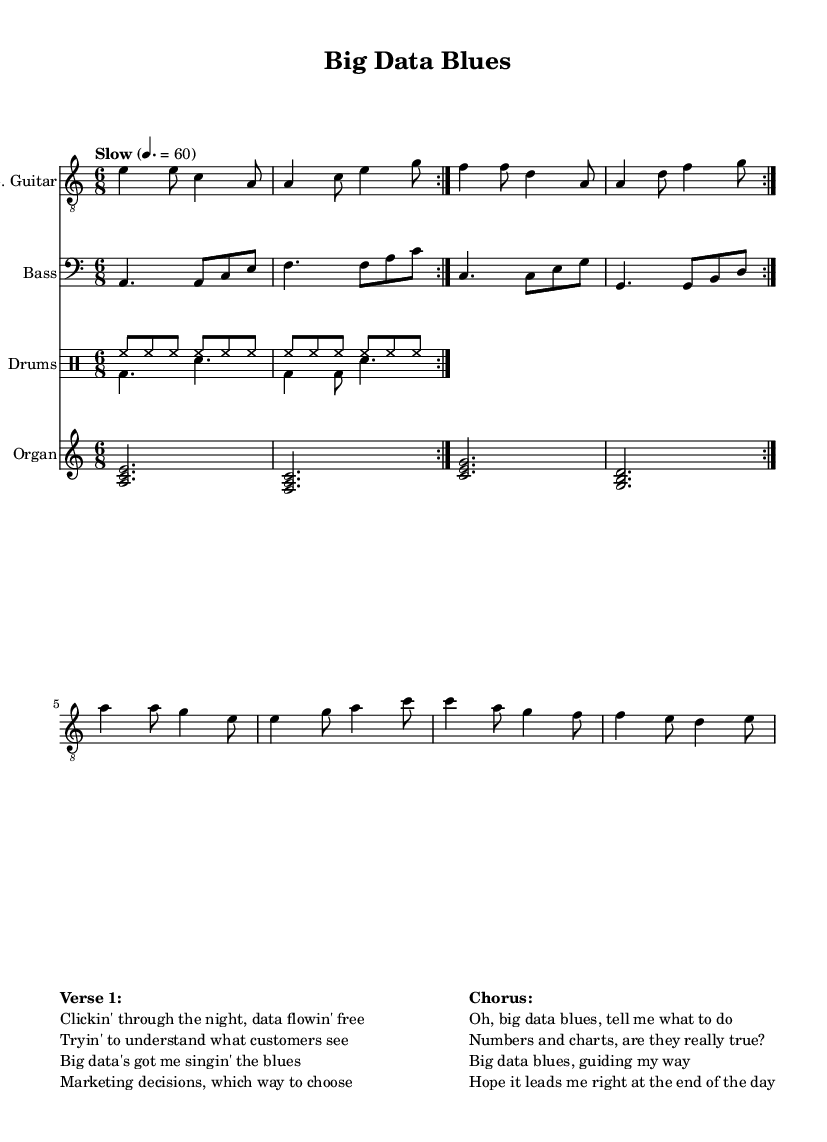What is the key signature of this music? The key signature is A minor, which has no sharps or flats as indicated at the beginning of the music staff.
Answer: A minor What is the time signature of this music? The time signature is 6/8, which is shown at the beginning of the score, indicating there are six eighth notes per measure.
Answer: 6/8 What is the tempo marking for this piece? The tempo marking states "Slow" with a metronome marking of quarter note equals 60, which sets a slow pace for the performance.
Answer: Slow, 60 How many measures are in the refrain? The refrain spans a total of 4 measures, divided across the phrases in the chorus section of the lyrics.
Answer: 4 What instruments are featured in this piece? The piece features an electric guitar, bass guitar, drums, and Hammond organ, as indicated by the staff names in the score.
Answer: Electric guitar, bass guitar, drums, Hammond organ What emotional theme does the song explore? The song explores the emotional impact of big data in marketing, as indicated by the lyrics reflecting on data flow and marketing decisions.
Answer: Emotional impact of big data in marketing 